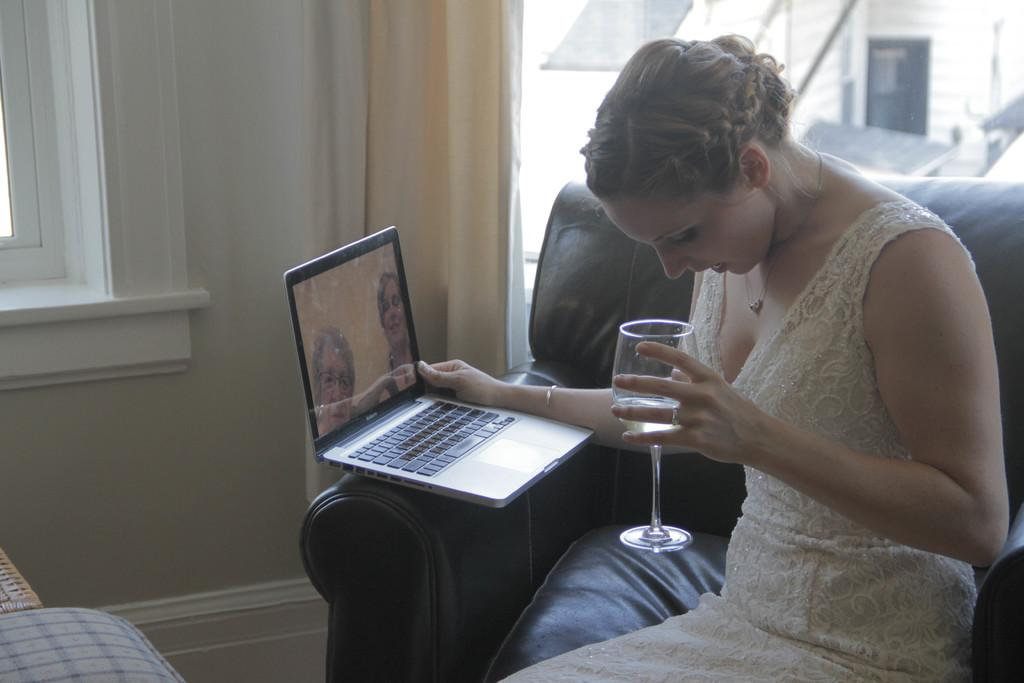Who is present in the image? There is a woman in the image. What is the woman doing in the image? The woman is sitting on a couch. What objects is the woman holding in the image? The woman is holding a laptop and a glass. What can be seen through the window in the image? There is a building visible outside the window. What type of cracker is the woman eating in the image? There is no cracker present in the image, and the woman is not eating anything. 